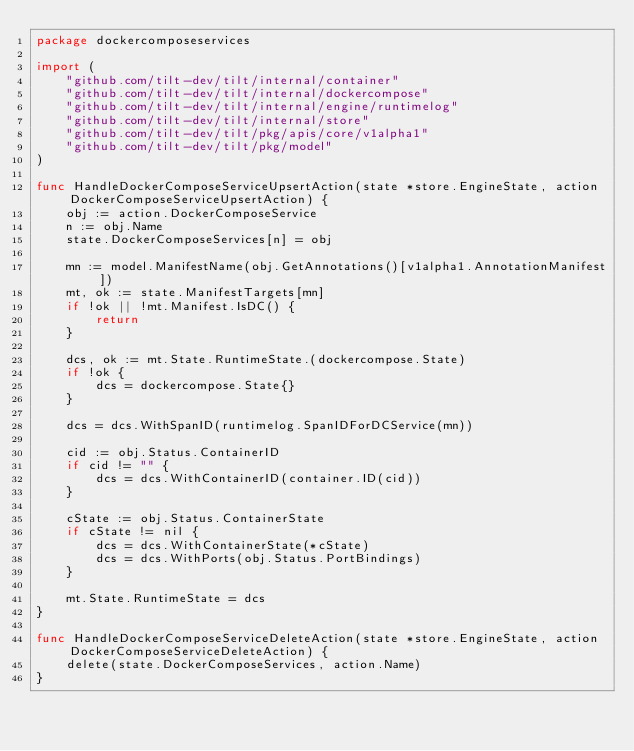<code> <loc_0><loc_0><loc_500><loc_500><_Go_>package dockercomposeservices

import (
	"github.com/tilt-dev/tilt/internal/container"
	"github.com/tilt-dev/tilt/internal/dockercompose"
	"github.com/tilt-dev/tilt/internal/engine/runtimelog"
	"github.com/tilt-dev/tilt/internal/store"
	"github.com/tilt-dev/tilt/pkg/apis/core/v1alpha1"
	"github.com/tilt-dev/tilt/pkg/model"
)

func HandleDockerComposeServiceUpsertAction(state *store.EngineState, action DockerComposeServiceUpsertAction) {
	obj := action.DockerComposeService
	n := obj.Name
	state.DockerComposeServices[n] = obj

	mn := model.ManifestName(obj.GetAnnotations()[v1alpha1.AnnotationManifest])
	mt, ok := state.ManifestTargets[mn]
	if !ok || !mt.Manifest.IsDC() {
		return
	}

	dcs, ok := mt.State.RuntimeState.(dockercompose.State)
	if !ok {
		dcs = dockercompose.State{}
	}

	dcs = dcs.WithSpanID(runtimelog.SpanIDForDCService(mn))

	cid := obj.Status.ContainerID
	if cid != "" {
		dcs = dcs.WithContainerID(container.ID(cid))
	}

	cState := obj.Status.ContainerState
	if cState != nil {
		dcs = dcs.WithContainerState(*cState)
		dcs = dcs.WithPorts(obj.Status.PortBindings)
	}

	mt.State.RuntimeState = dcs
}

func HandleDockerComposeServiceDeleteAction(state *store.EngineState, action DockerComposeServiceDeleteAction) {
	delete(state.DockerComposeServices, action.Name)
}
</code> 